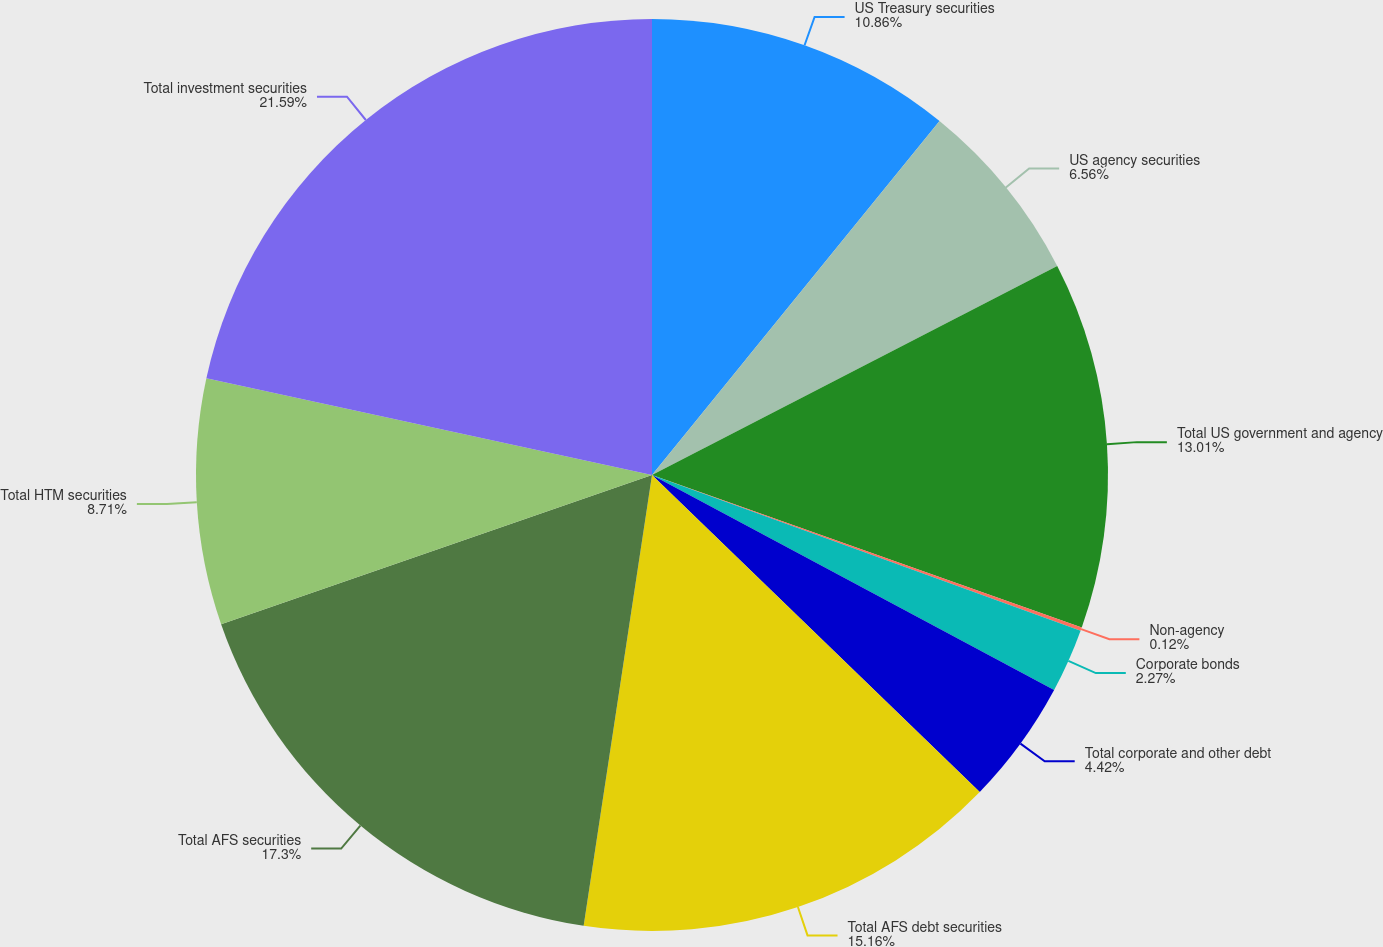Convert chart. <chart><loc_0><loc_0><loc_500><loc_500><pie_chart><fcel>US Treasury securities<fcel>US agency securities<fcel>Total US government and agency<fcel>Non-agency<fcel>Corporate bonds<fcel>Total corporate and other debt<fcel>Total AFS debt securities<fcel>Total AFS securities<fcel>Total HTM securities<fcel>Total investment securities<nl><fcel>10.86%<fcel>6.56%<fcel>13.01%<fcel>0.12%<fcel>2.27%<fcel>4.42%<fcel>15.16%<fcel>17.3%<fcel>8.71%<fcel>21.6%<nl></chart> 